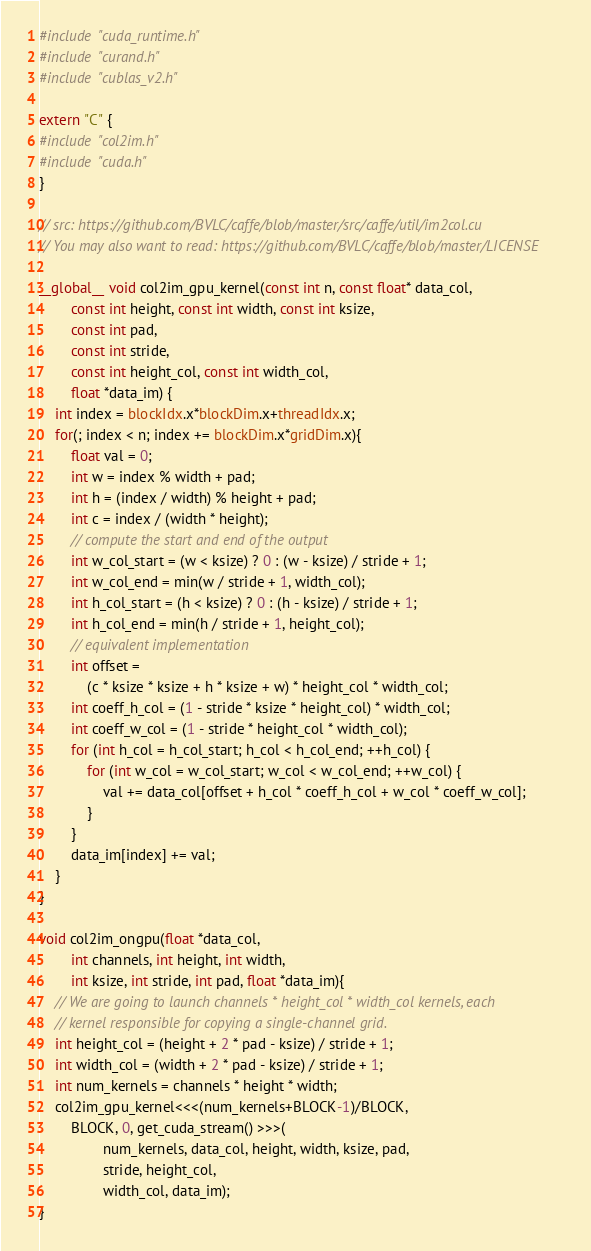Convert code to text. <code><loc_0><loc_0><loc_500><loc_500><_Cuda_>#include "cuda_runtime.h"
#include "curand.h"
#include "cublas_v2.h"

extern "C" {
#include "col2im.h"
#include "cuda.h"
}

// src: https://github.com/BVLC/caffe/blob/master/src/caffe/util/im2col.cu
// You may also want to read: https://github.com/BVLC/caffe/blob/master/LICENSE

__global__ void col2im_gpu_kernel(const int n, const float* data_col,
        const int height, const int width, const int ksize,
        const int pad,
        const int stride,
        const int height_col, const int width_col,
        float *data_im) {
    int index = blockIdx.x*blockDim.x+threadIdx.x;
    for(; index < n; index += blockDim.x*gridDim.x){
        float val = 0;
        int w = index % width + pad;
        int h = (index / width) % height + pad;
        int c = index / (width * height);
        // compute the start and end of the output
        int w_col_start = (w < ksize) ? 0 : (w - ksize) / stride + 1;
        int w_col_end = min(w / stride + 1, width_col);
        int h_col_start = (h < ksize) ? 0 : (h - ksize) / stride + 1;
        int h_col_end = min(h / stride + 1, height_col);
        // equivalent implementation
        int offset =
            (c * ksize * ksize + h * ksize + w) * height_col * width_col;
        int coeff_h_col = (1 - stride * ksize * height_col) * width_col;
        int coeff_w_col = (1 - stride * height_col * width_col);
        for (int h_col = h_col_start; h_col < h_col_end; ++h_col) {
            for (int w_col = w_col_start; w_col < w_col_end; ++w_col) {
                val += data_col[offset + h_col * coeff_h_col + w_col * coeff_w_col];
            }
        }
        data_im[index] += val;
    }
}

void col2im_ongpu(float *data_col,
        int channels, int height, int width,
        int ksize, int stride, int pad, float *data_im){
    // We are going to launch channels * height_col * width_col kernels, each
    // kernel responsible for copying a single-channel grid.
    int height_col = (height + 2 * pad - ksize) / stride + 1;
    int width_col = (width + 2 * pad - ksize) / stride + 1;
    int num_kernels = channels * height * width;
    col2im_gpu_kernel<<<(num_kernels+BLOCK-1)/BLOCK,
        BLOCK, 0, get_cuda_stream() >>>(
                num_kernels, data_col, height, width, ksize, pad,
                stride, height_col,
                width_col, data_im);
}

</code> 